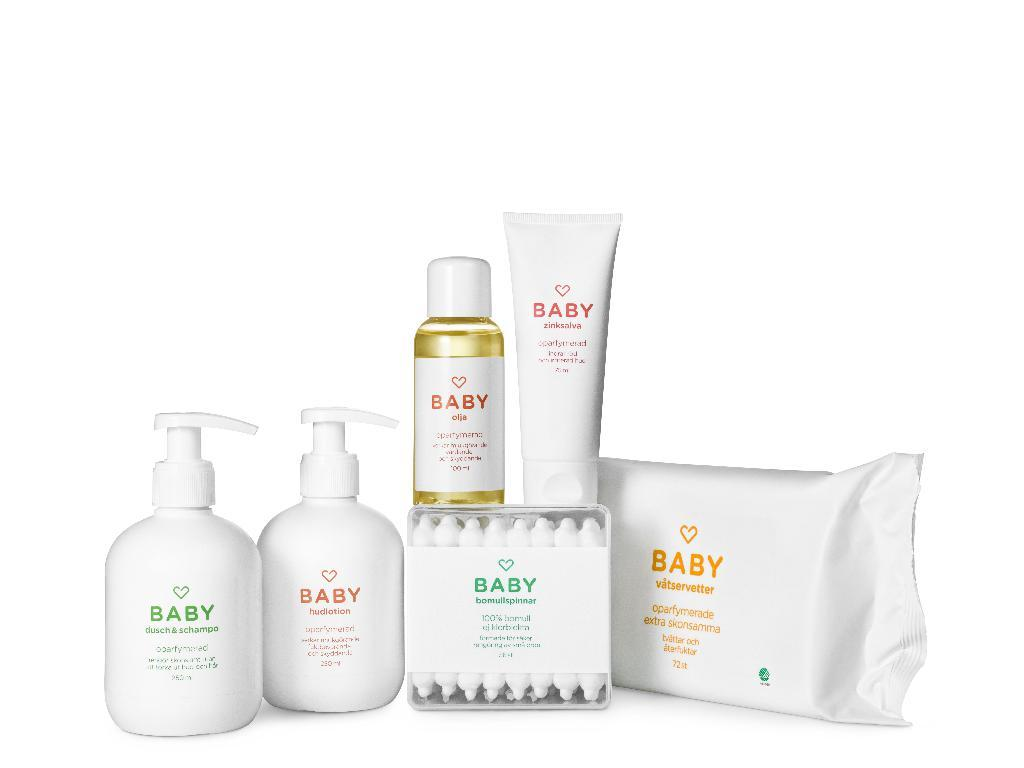<image>
Write a terse but informative summary of the picture. Products from the Baby brand in white packages with simple labels. 